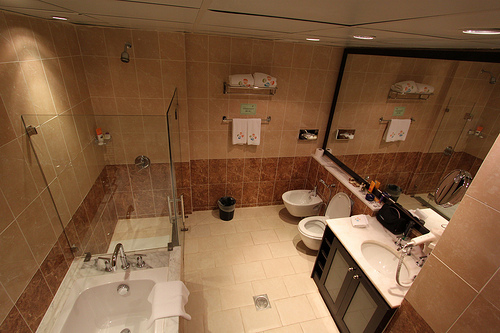What type of bathtub is that, and does it have any special features? That appears to be a built-in alcove bathtub, characterized by its design fitted into a three-wall recess. It includes a handheld showerhead, offering versatility for bathing. 